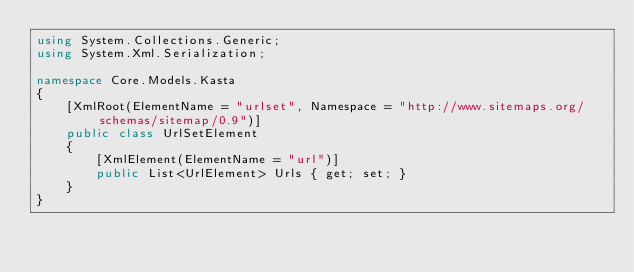Convert code to text. <code><loc_0><loc_0><loc_500><loc_500><_C#_>using System.Collections.Generic;
using System.Xml.Serialization;

namespace Core.Models.Kasta
{
    [XmlRoot(ElementName = "urlset", Namespace = "http://www.sitemaps.org/schemas/sitemap/0.9")]
    public class UrlSetElement
    {
        [XmlElement(ElementName = "url")]
        public List<UrlElement> Urls { get; set; }
    }
}</code> 